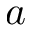Convert formula to latex. <formula><loc_0><loc_0><loc_500><loc_500>a</formula> 